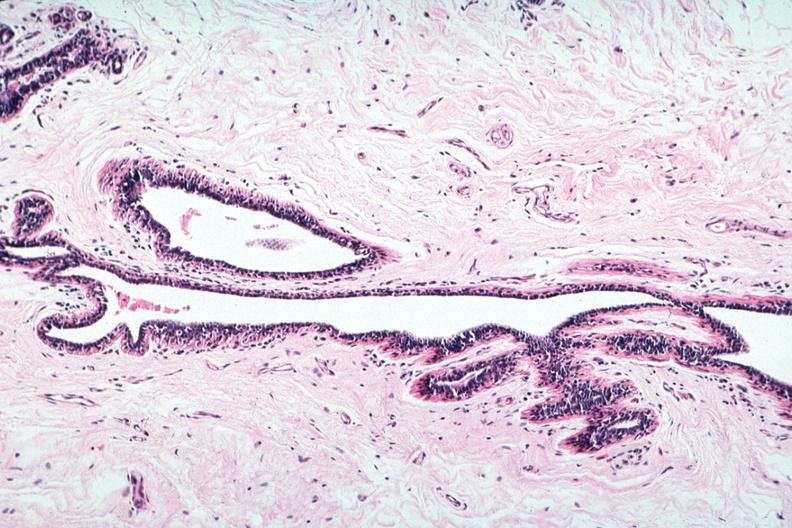s breast present?
Answer the question using a single word or phrase. Yes 